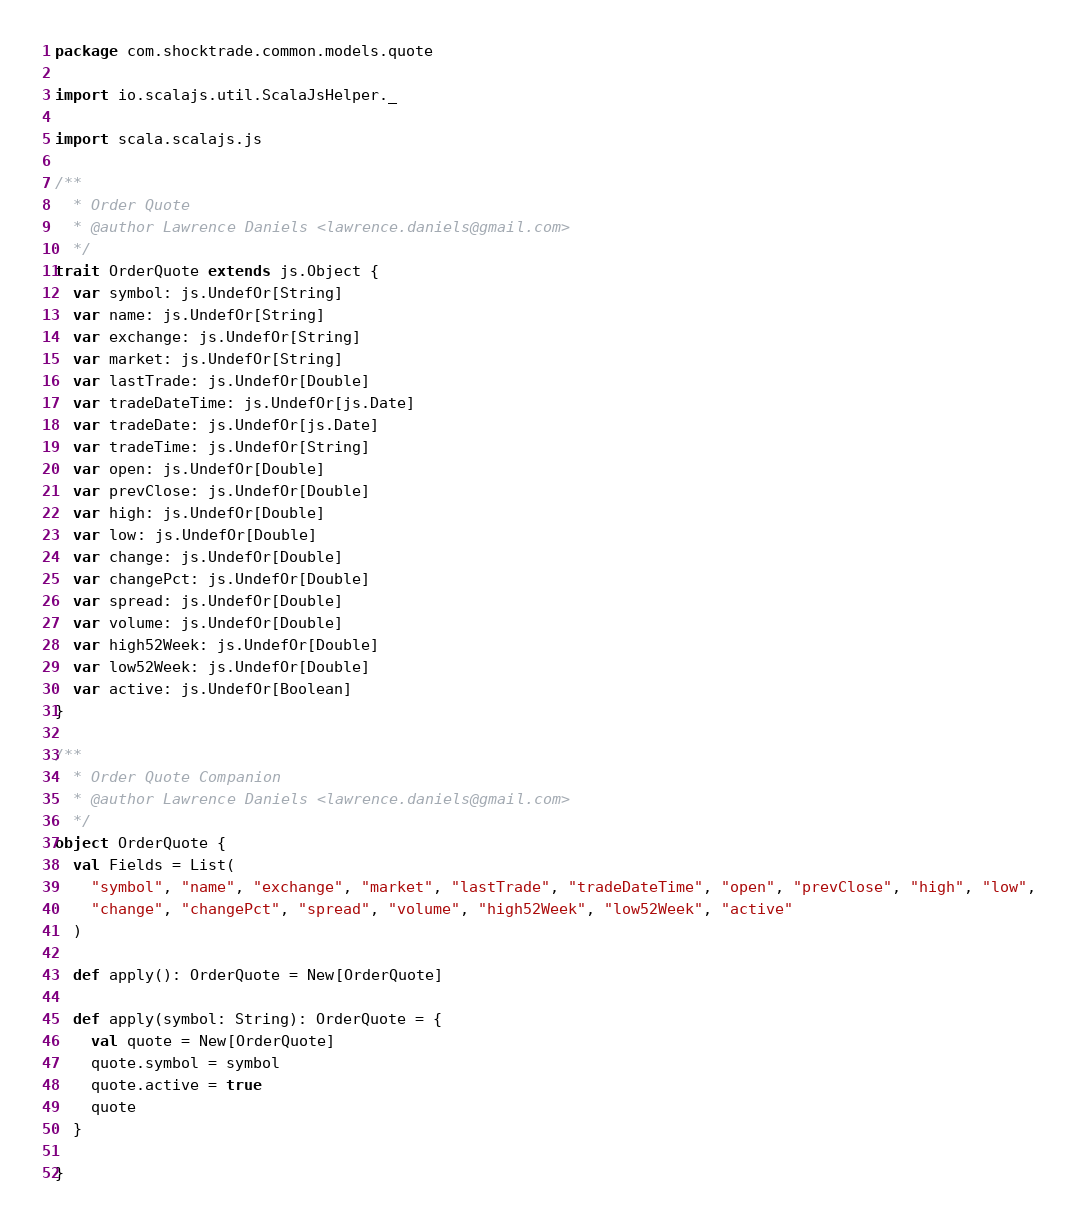<code> <loc_0><loc_0><loc_500><loc_500><_Scala_>package com.shocktrade.common.models.quote

import io.scalajs.util.ScalaJsHelper._

import scala.scalajs.js

/**
  * Order Quote
  * @author Lawrence Daniels <lawrence.daniels@gmail.com>
  */
trait OrderQuote extends js.Object {
  var symbol: js.UndefOr[String]
  var name: js.UndefOr[String]
  var exchange: js.UndefOr[String]
  var market: js.UndefOr[String]
  var lastTrade: js.UndefOr[Double]
  var tradeDateTime: js.UndefOr[js.Date]
  var tradeDate: js.UndefOr[js.Date]
  var tradeTime: js.UndefOr[String]
  var open: js.UndefOr[Double]
  var prevClose: js.UndefOr[Double]
  var high: js.UndefOr[Double]
  var low: js.UndefOr[Double]
  var change: js.UndefOr[Double]
  var changePct: js.UndefOr[Double]
  var spread: js.UndefOr[Double]
  var volume: js.UndefOr[Double]
  var high52Week: js.UndefOr[Double]
  var low52Week: js.UndefOr[Double]
  var active: js.UndefOr[Boolean]
}

/**
  * Order Quote Companion
  * @author Lawrence Daniels <lawrence.daniels@gmail.com>
  */
object OrderQuote {
  val Fields = List(
    "symbol", "name", "exchange", "market", "lastTrade", "tradeDateTime", "open", "prevClose", "high", "low",
    "change", "changePct", "spread", "volume", "high52Week", "low52Week", "active"
  )

  def apply(): OrderQuote = New[OrderQuote]

  def apply(symbol: String): OrderQuote = {
    val quote = New[OrderQuote]
    quote.symbol = symbol
    quote.active = true
    quote
  }

}</code> 